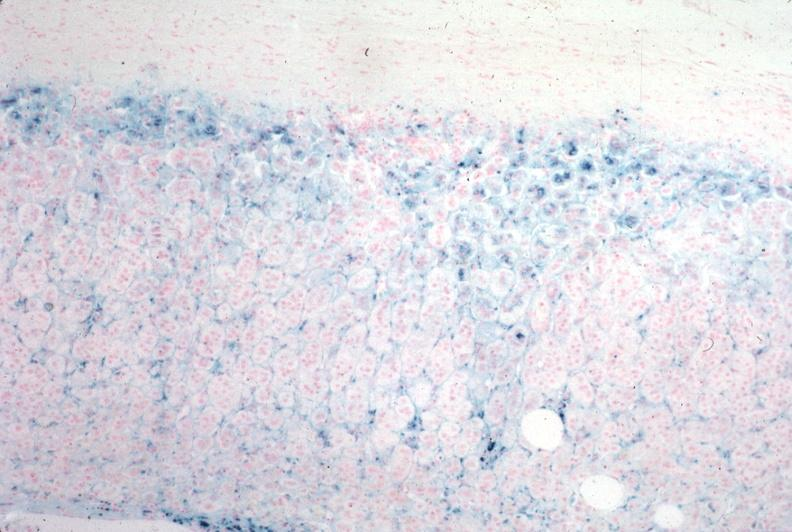what is present?
Answer the question using a single word or phrase. Adrenal 